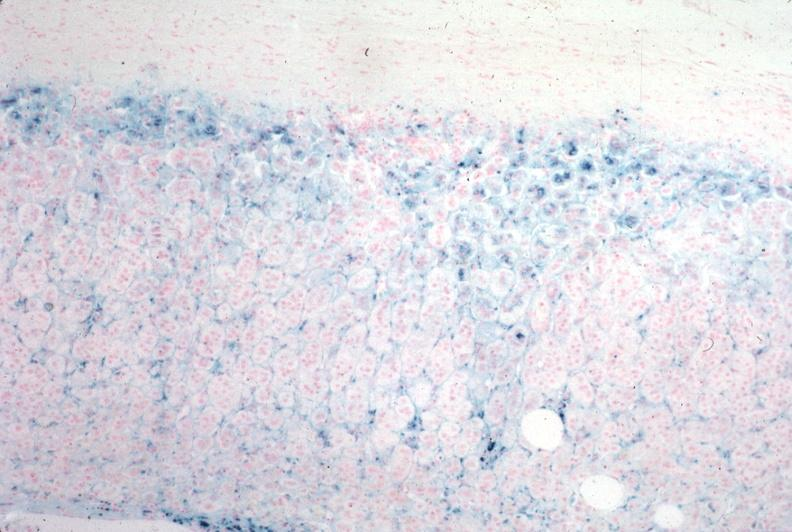what is present?
Answer the question using a single word or phrase. Adrenal 